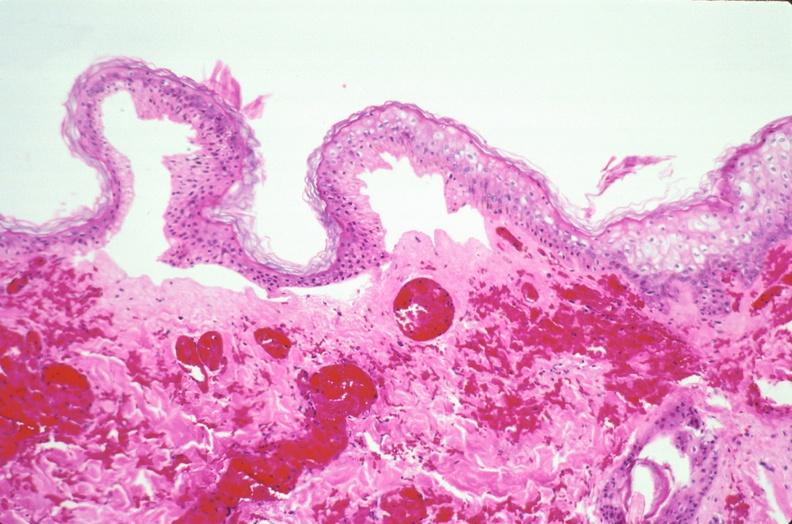what does this image show?
Answer the question using a single word or phrase. Skin 